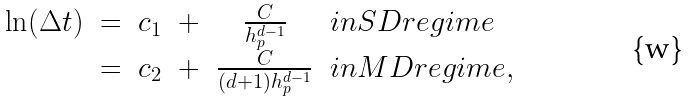Convert formula to latex. <formula><loc_0><loc_0><loc_500><loc_500>\begin{array} { c c c c c l } \ln ( \Delta t ) & = & c _ { 1 } & + & \frac { C } { h _ { p } ^ { d - 1 } } & i n S D r e g i m e \\ & = & c _ { 2 } & + & \frac { C } { ( d + 1 ) h _ { p } ^ { d - 1 } } & i n M D r e g i m e , \end{array}</formula> 